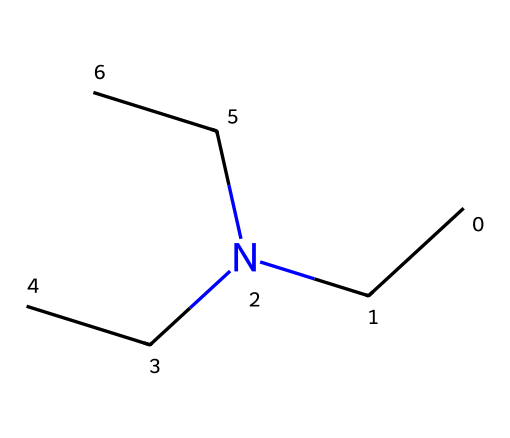What is the chemical name associated with the provided structure? The SMILES representation CCN(CC)CC corresponds to triethylamine, which is identified by its structure containing a nitrogen atom bonded to three ethyl groups (C2H5).
Answer: triethylamine How many nitrogen atoms are in this chemical structure? The SMILES shows one 'N' in the representation CCN(CC)CC, indicating there is one nitrogen atom.
Answer: 1 What is the total number of carbon atoms in triethylamine? Each ethyl group (C2H5) contributes two carbon atoms, and there are three ethyl groups, giving a total of 6 carbon atoms.
Answer: 6 What type of bonding is primarily found between the carbon and nitrogen atoms in triethylamine? The bonds between the carbon atoms and the nitrogen atom are covalent bonds, which are formed by the sharing of electron pairs.
Answer: covalent How many hydrogens are bonded to the nitrogen atom in triethylamine? The nitrogen atom in triethylamine is bonded to three ethyl groups, each containing 5 hydrogens, but since nitrogen can only form three bonds, the number of hydrogens bonded directly to nitrogen is 0.
Answer: 0 Is triethylamine a polar or nonpolar molecule? The presence of the nitrogen atom and the distribution of electron density due to the ethyl groups lead to a net dipole moment in the molecule, making it polar.
Answer: polar 